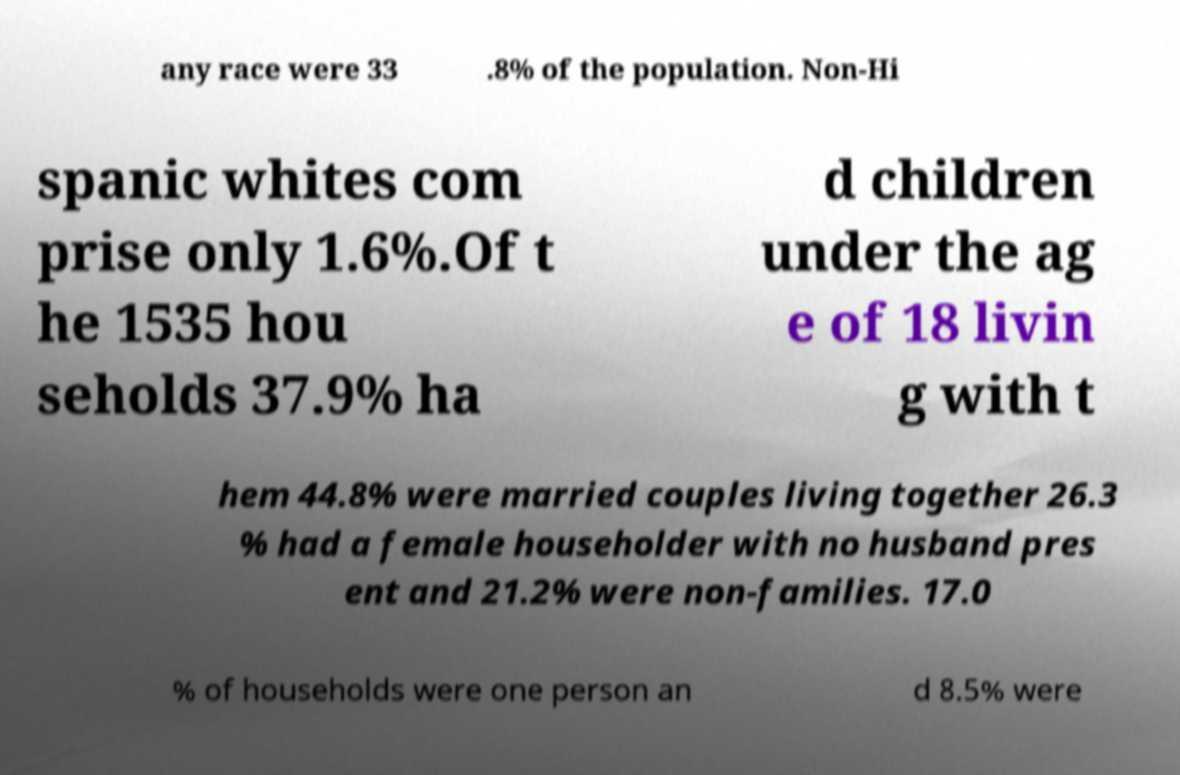Could you assist in decoding the text presented in this image and type it out clearly? any race were 33 .8% of the population. Non-Hi spanic whites com prise only 1.6%.Of t he 1535 hou seholds 37.9% ha d children under the ag e of 18 livin g with t hem 44.8% were married couples living together 26.3 % had a female householder with no husband pres ent and 21.2% were non-families. 17.0 % of households were one person an d 8.5% were 